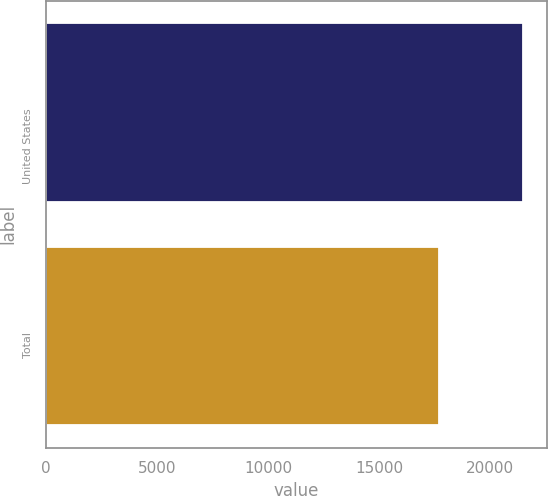Convert chart. <chart><loc_0><loc_0><loc_500><loc_500><bar_chart><fcel>United States<fcel>Total<nl><fcel>21495<fcel>17680<nl></chart> 